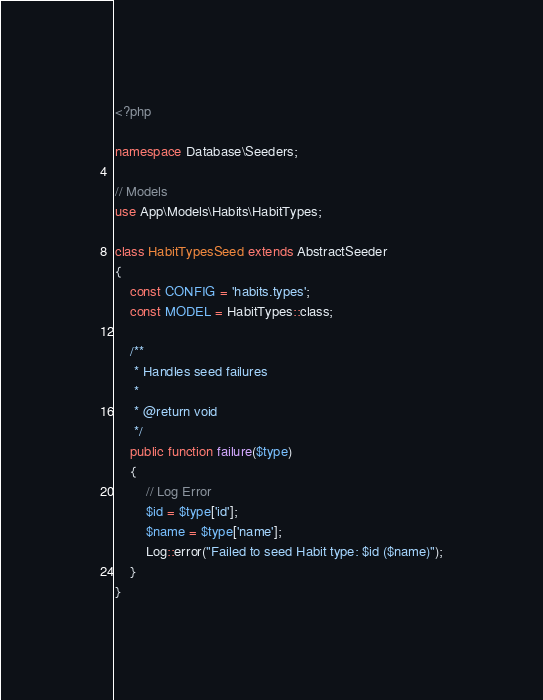<code> <loc_0><loc_0><loc_500><loc_500><_PHP_><?php

namespace Database\Seeders;

// Models
use App\Models\Habits\HabitTypes;

class HabitTypesSeed extends AbstractSeeder
{
    const CONFIG = 'habits.types';
    const MODEL = HabitTypes::class;

    /**
     * Handles seed failures
     *
     * @return void
     */
    public function failure($type)
    {
        // Log Error
        $id = $type['id'];
        $name = $type['name'];
        Log::error("Failed to seed Habit type: $id ($name)");
    }
}
</code> 